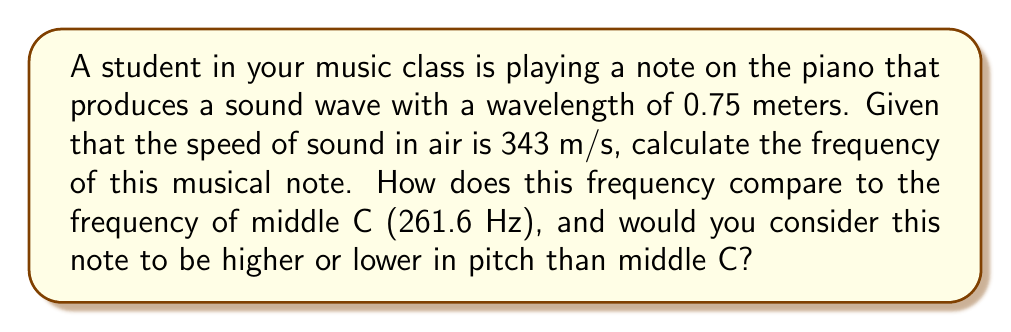Can you answer this question? Let's approach this step-by-step:

1) The relationship between frequency ($f$), wavelength ($\lambda$), and speed of sound ($v$) is given by the equation:

   $$v = f \lambda$$

2) We know:
   - Speed of sound, $v = 343$ m/s
   - Wavelength, $\lambda = 0.75$ m

3) Rearranging the equation to solve for frequency:

   $$f = \frac{v}{\lambda}$$

4) Substituting the known values:

   $$f = \frac{343 \text{ m/s}}{0.75 \text{ m}}$$

5) Calculating:

   $$f = 457.33 \text{ Hz}$$

6) Comparing to middle C (261.6 Hz):
   457.33 Hz > 261.6 Hz

7) Since the frequency is higher than middle C, this note has a higher pitch.

This frequency is closer to the A4 note (440 Hz) on a piano, which is above middle C. As a music teacher, you might relate this to the fact that notes to the right of middle C on a piano have higher frequencies and pitches, much like how classical music often has higher pitched melodies compared to the bass lines in modern rap.
Answer: 457.33 Hz; higher pitch than middle C 